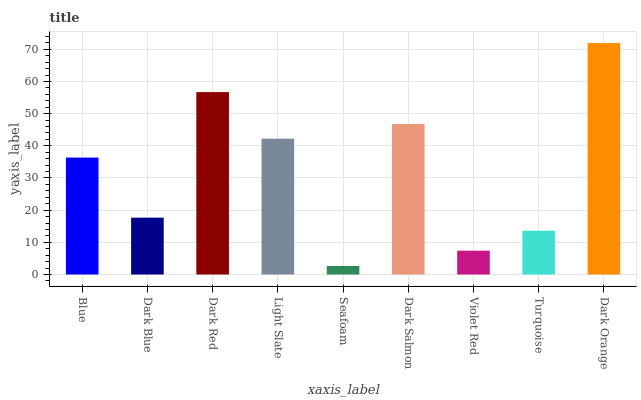Is Seafoam the minimum?
Answer yes or no. Yes. Is Dark Orange the maximum?
Answer yes or no. Yes. Is Dark Blue the minimum?
Answer yes or no. No. Is Dark Blue the maximum?
Answer yes or no. No. Is Blue greater than Dark Blue?
Answer yes or no. Yes. Is Dark Blue less than Blue?
Answer yes or no. Yes. Is Dark Blue greater than Blue?
Answer yes or no. No. Is Blue less than Dark Blue?
Answer yes or no. No. Is Blue the high median?
Answer yes or no. Yes. Is Blue the low median?
Answer yes or no. Yes. Is Dark Orange the high median?
Answer yes or no. No. Is Dark Red the low median?
Answer yes or no. No. 